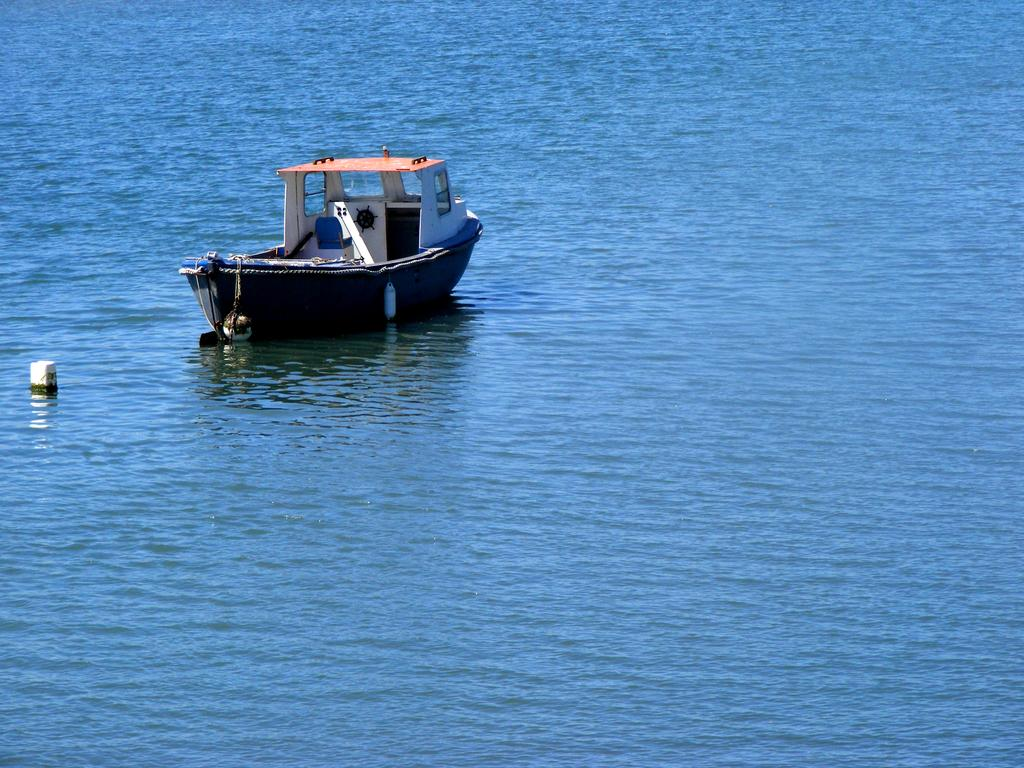What is the main subject of the image? The main subject of the image is a boat. Where is the boat located in the image? The boat is on the water in the image. What can be inferred about the setting of the image? The setting of the image is likely a body of water, given that the boat is on the water. How much salt is present in the image? There is no salt present in the image. 